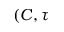<formula> <loc_0><loc_0><loc_500><loc_500>( C , \tau</formula> 